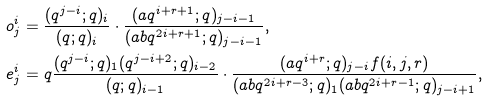Convert formula to latex. <formula><loc_0><loc_0><loc_500><loc_500>o ^ { i } _ { j } & = \frac { ( q ^ { j - i } ; q ) _ { i } } { ( q ; q ) _ { i } } \cdot \frac { ( a q ^ { i + r + 1 } ; q ) _ { j - i - 1 } } { ( a b q ^ { 2 i + r + 1 } ; q ) _ { j - i - 1 } } , \\ e ^ { i } _ { j } & = q \frac { ( q ^ { j - i } ; q ) _ { 1 } ( q ^ { j - i + 2 } ; q ) _ { i - 2 } } { ( q ; q ) _ { i - 1 } } \cdot \frac { ( a q ^ { i + r } ; q ) _ { j - i } f ( i , j , r ) } { ( a b q ^ { 2 i + r - 3 } ; q ) _ { 1 } ( a b q ^ { 2 i + r - 1 } ; q ) _ { j - i + 1 } } ,</formula> 